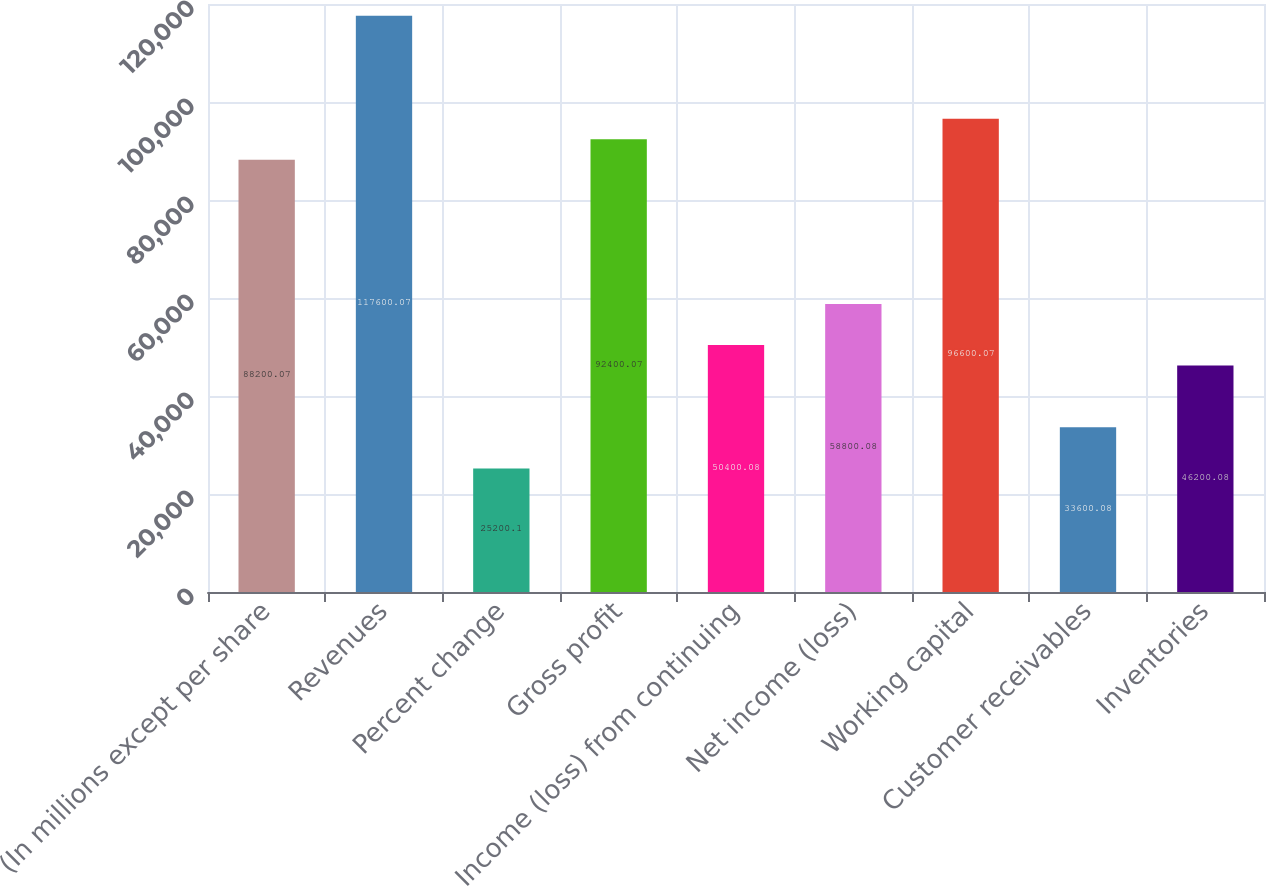Convert chart to OTSL. <chart><loc_0><loc_0><loc_500><loc_500><bar_chart><fcel>(In millions except per share<fcel>Revenues<fcel>Percent change<fcel>Gross profit<fcel>Income (loss) from continuing<fcel>Net income (loss)<fcel>Working capital<fcel>Customer receivables<fcel>Inventories<nl><fcel>88200.1<fcel>117600<fcel>25200.1<fcel>92400.1<fcel>50400.1<fcel>58800.1<fcel>96600.1<fcel>33600.1<fcel>46200.1<nl></chart> 